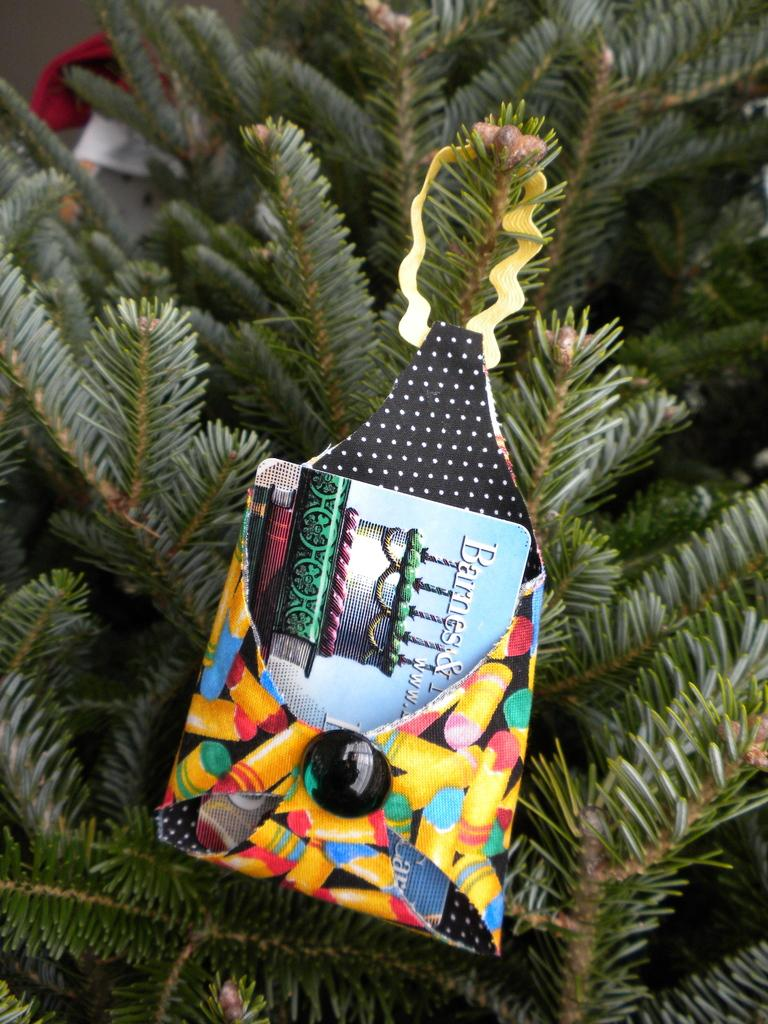What type of natural element is present in the image? There is a tree in the image. What is attached to the tree in the image? There is an object hanged to the tree. What is inside the object that is attached to the tree? There is a card in the object. What type of learning material can be seen being distributed by the hydrant in the image? There is no hydrant present in the image, and therefore no distribution of learning materials can be observed. 